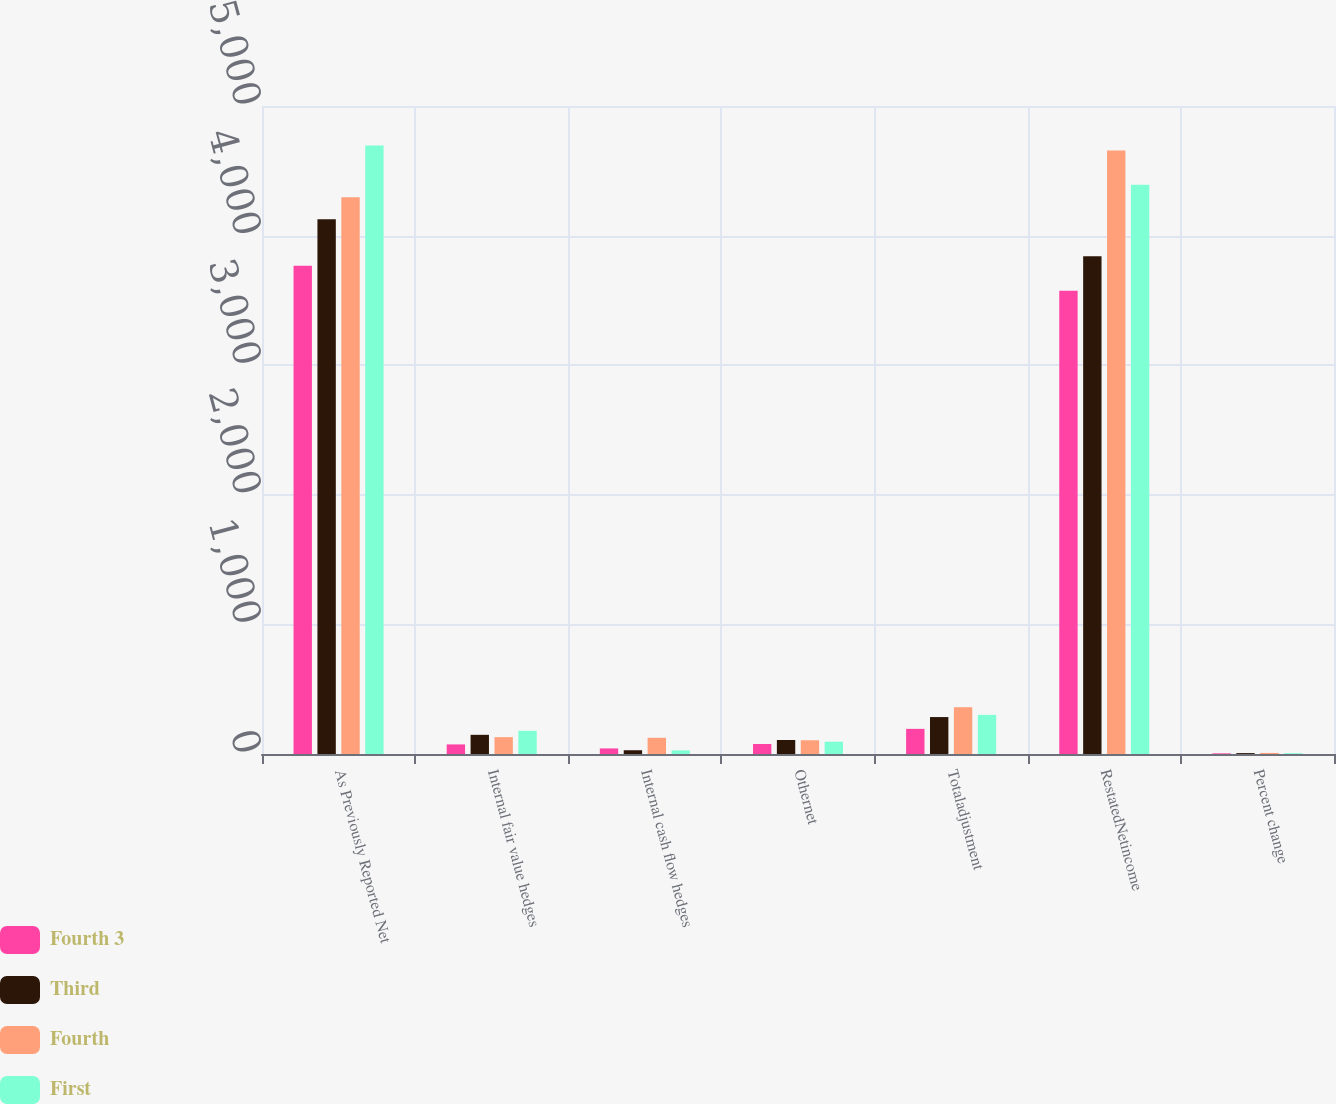<chart> <loc_0><loc_0><loc_500><loc_500><stacked_bar_chart><ecel><fcel>As Previously Reported Net<fcel>Internal fair value hedges<fcel>Internal cash flow hedges<fcel>Othernet<fcel>Totaladjustment<fcel>RestatedNetincome<fcel>Percent change<nl><fcel>Fourth 3<fcel>3768<fcel>74<fcel>43<fcel>77<fcel>194<fcel>3574<fcel>5.1<nl><fcel>Third<fcel>4127<fcel>148<fcel>29<fcel>108<fcel>285<fcel>3841<fcel>6.9<nl><fcel>Fourth<fcel>4296<fcel>130<fcel>125<fcel>106<fcel>361<fcel>4657<fcel>8.4<nl><fcel>First<fcel>4695<fcel>179<fcel>28<fcel>95<fcel>302<fcel>4393<fcel>6.4<nl></chart> 